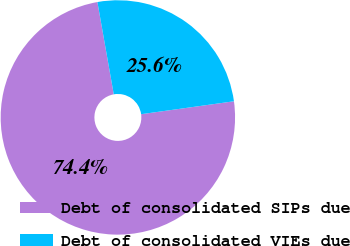<chart> <loc_0><loc_0><loc_500><loc_500><pie_chart><fcel>Debt of consolidated SIPs due<fcel>Debt of consolidated VIEs due<nl><fcel>74.41%<fcel>25.59%<nl></chart> 